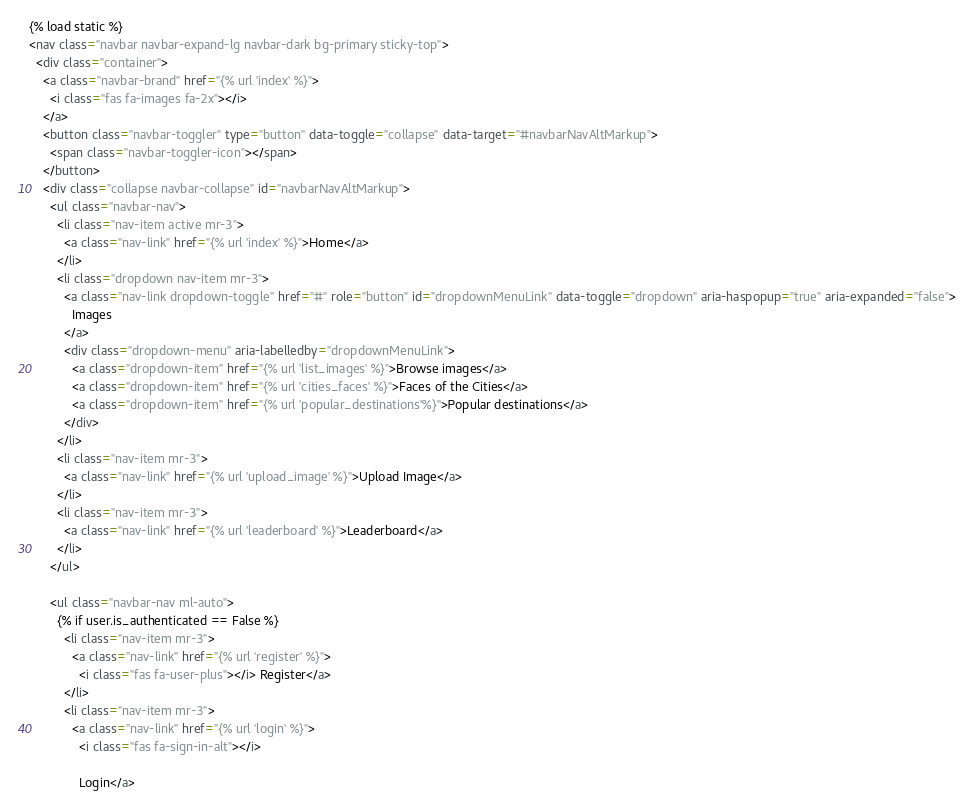Convert code to text. <code><loc_0><loc_0><loc_500><loc_500><_HTML_>{% load static %}
<nav class="navbar navbar-expand-lg navbar-dark bg-primary sticky-top">
  <div class="container">
    <a class="navbar-brand" href="{% url 'index' %}">
      <i class="fas fa-images fa-2x"></i>
    </a>
    <button class="navbar-toggler" type="button" data-toggle="collapse" data-target="#navbarNavAltMarkup">
      <span class="navbar-toggler-icon"></span>
    </button>
    <div class="collapse navbar-collapse" id="navbarNavAltMarkup">
      <ul class="navbar-nav">
        <li class="nav-item active mr-3">
          <a class="nav-link" href="{% url 'index' %}">Home</a>
        </li>
        <li class="dropdown nav-item mr-3">
          <a class="nav-link dropdown-toggle" href="#" role="button" id="dropdownMenuLink" data-toggle="dropdown" aria-haspopup="true" aria-expanded="false">
            Images
          </a>
          <div class="dropdown-menu" aria-labelledby="dropdownMenuLink">
            <a class="dropdown-item" href="{% url 'list_images' %}">Browse images</a>
            <a class="dropdown-item" href="{% url 'cities_faces' %}">Faces of the Cities</a>
            <a class="dropdown-item" href="{% url 'popular_destinations'%}">Popular destinations</a>
          </div>
        </li>
        <li class="nav-item mr-3">
          <a class="nav-link" href="{% url 'upload_image' %}">Upload Image</a>
        </li>
        <li class="nav-item mr-3">
          <a class="nav-link" href="{% url 'leaderboard' %}">Leaderboard</a>
        </li>
      </ul>

      <ul class="navbar-nav ml-auto">
        {% if user.is_authenticated == False %}
          <li class="nav-item mr-3">
            <a class="nav-link" href="{% url 'register' %}">
              <i class="fas fa-user-plus"></i> Register</a>
          </li>
          <li class="nav-item mr-3">
            <a class="nav-link" href="{% url 'login' %}">
              <i class="fas fa-sign-in-alt"></i>

              Login</a></code> 